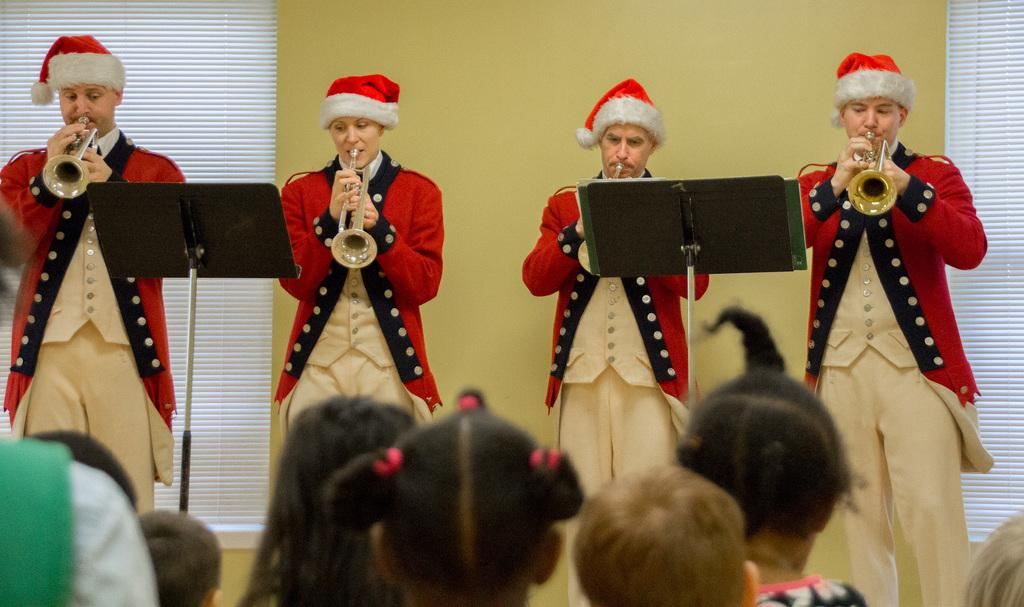What are the people in the image doing? The people in the image are standing and playing musical instruments. What objects can be seen in the image besides the people? There are stands in the image. What can be seen in the background of the image? There is a wall and window shades in the background of the image. Can you tell me how many maids are visible in the image? There are no maids present in the image. What type of waves can be seen in the image? There are no waves visible in the image. 